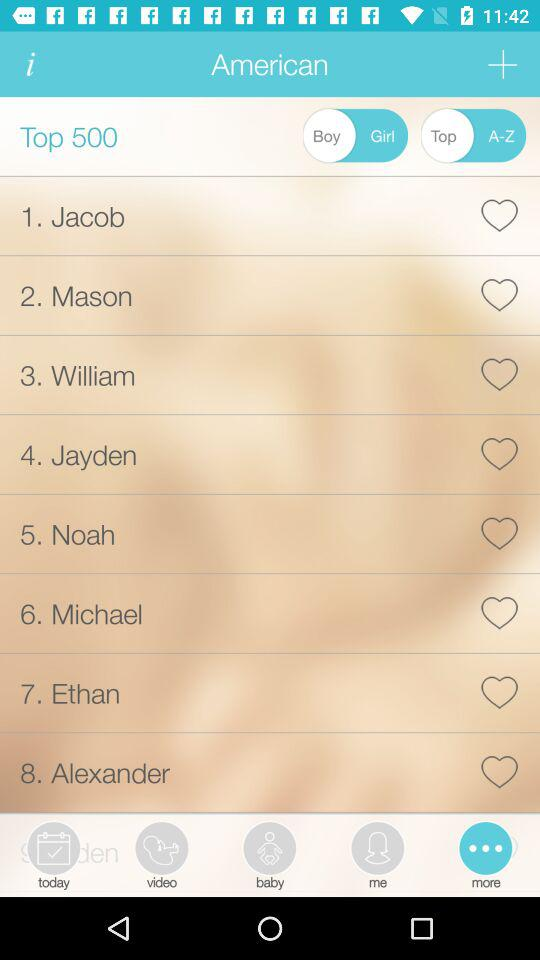What is the status of Top 500?
When the provided information is insufficient, respond with <no answer>. <no answer> 